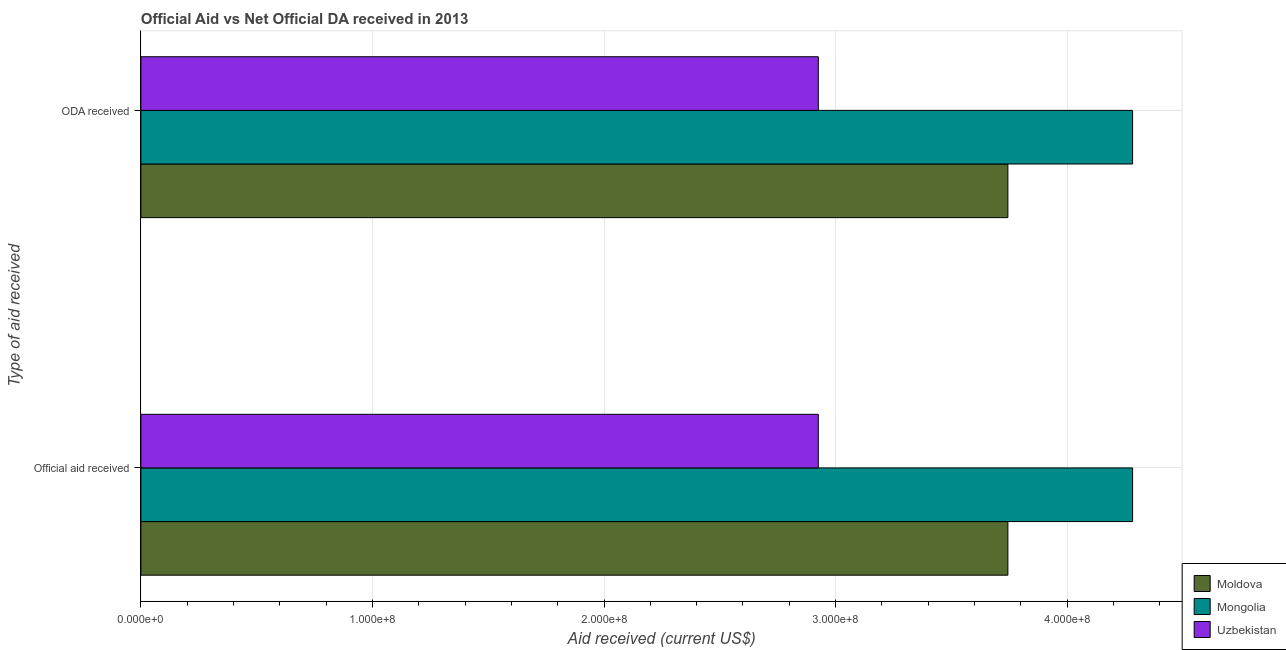How many groups of bars are there?
Your answer should be compact. 2. Are the number of bars per tick equal to the number of legend labels?
Offer a terse response. Yes. How many bars are there on the 1st tick from the top?
Keep it short and to the point. 3. What is the label of the 1st group of bars from the top?
Give a very brief answer. ODA received. What is the oda received in Moldova?
Keep it short and to the point. 3.74e+08. Across all countries, what is the maximum official aid received?
Your response must be concise. 4.28e+08. Across all countries, what is the minimum oda received?
Your answer should be very brief. 2.93e+08. In which country was the official aid received maximum?
Your answer should be very brief. Mongolia. In which country was the oda received minimum?
Give a very brief answer. Uzbekistan. What is the total oda received in the graph?
Your response must be concise. 1.10e+09. What is the difference between the official aid received in Uzbekistan and that in Moldova?
Ensure brevity in your answer.  -8.19e+07. What is the difference between the official aid received in Moldova and the oda received in Uzbekistan?
Your answer should be very brief. 8.19e+07. What is the average oda received per country?
Your answer should be compact. 3.65e+08. In how many countries, is the oda received greater than 100000000 US$?
Make the answer very short. 3. What is the ratio of the oda received in Moldova to that in Mongolia?
Offer a very short reply. 0.87. Is the official aid received in Moldova less than that in Uzbekistan?
Offer a very short reply. No. In how many countries, is the oda received greater than the average oda received taken over all countries?
Keep it short and to the point. 2. What does the 2nd bar from the top in Official aid received represents?
Provide a short and direct response. Mongolia. What does the 3rd bar from the bottom in Official aid received represents?
Your response must be concise. Uzbekistan. Are the values on the major ticks of X-axis written in scientific E-notation?
Your answer should be very brief. Yes. Does the graph contain grids?
Make the answer very short. Yes. Where does the legend appear in the graph?
Your answer should be compact. Bottom right. How many legend labels are there?
Your answer should be very brief. 3. How are the legend labels stacked?
Ensure brevity in your answer.  Vertical. What is the title of the graph?
Give a very brief answer. Official Aid vs Net Official DA received in 2013 . Does "Niger" appear as one of the legend labels in the graph?
Offer a very short reply. No. What is the label or title of the X-axis?
Make the answer very short. Aid received (current US$). What is the label or title of the Y-axis?
Provide a short and direct response. Type of aid received. What is the Aid received (current US$) of Moldova in Official aid received?
Give a very brief answer. 3.74e+08. What is the Aid received (current US$) in Mongolia in Official aid received?
Keep it short and to the point. 4.28e+08. What is the Aid received (current US$) in Uzbekistan in Official aid received?
Provide a short and direct response. 2.93e+08. What is the Aid received (current US$) of Moldova in ODA received?
Make the answer very short. 3.74e+08. What is the Aid received (current US$) of Mongolia in ODA received?
Give a very brief answer. 4.28e+08. What is the Aid received (current US$) in Uzbekistan in ODA received?
Offer a terse response. 2.93e+08. Across all Type of aid received, what is the maximum Aid received (current US$) in Moldova?
Your answer should be very brief. 3.74e+08. Across all Type of aid received, what is the maximum Aid received (current US$) in Mongolia?
Your answer should be very brief. 4.28e+08. Across all Type of aid received, what is the maximum Aid received (current US$) in Uzbekistan?
Your response must be concise. 2.93e+08. Across all Type of aid received, what is the minimum Aid received (current US$) in Moldova?
Offer a very short reply. 3.74e+08. Across all Type of aid received, what is the minimum Aid received (current US$) of Mongolia?
Your answer should be very brief. 4.28e+08. Across all Type of aid received, what is the minimum Aid received (current US$) of Uzbekistan?
Provide a short and direct response. 2.93e+08. What is the total Aid received (current US$) of Moldova in the graph?
Offer a terse response. 7.49e+08. What is the total Aid received (current US$) of Mongolia in the graph?
Ensure brevity in your answer.  8.57e+08. What is the total Aid received (current US$) in Uzbekistan in the graph?
Provide a short and direct response. 5.85e+08. What is the difference between the Aid received (current US$) in Uzbekistan in Official aid received and that in ODA received?
Your answer should be compact. 0. What is the difference between the Aid received (current US$) in Moldova in Official aid received and the Aid received (current US$) in Mongolia in ODA received?
Offer a very short reply. -5.38e+07. What is the difference between the Aid received (current US$) of Moldova in Official aid received and the Aid received (current US$) of Uzbekistan in ODA received?
Offer a very short reply. 8.19e+07. What is the difference between the Aid received (current US$) in Mongolia in Official aid received and the Aid received (current US$) in Uzbekistan in ODA received?
Provide a short and direct response. 1.36e+08. What is the average Aid received (current US$) in Moldova per Type of aid received?
Offer a terse response. 3.74e+08. What is the average Aid received (current US$) of Mongolia per Type of aid received?
Your answer should be very brief. 4.28e+08. What is the average Aid received (current US$) in Uzbekistan per Type of aid received?
Keep it short and to the point. 2.93e+08. What is the difference between the Aid received (current US$) of Moldova and Aid received (current US$) of Mongolia in Official aid received?
Your response must be concise. -5.38e+07. What is the difference between the Aid received (current US$) in Moldova and Aid received (current US$) in Uzbekistan in Official aid received?
Provide a short and direct response. 8.19e+07. What is the difference between the Aid received (current US$) in Mongolia and Aid received (current US$) in Uzbekistan in Official aid received?
Give a very brief answer. 1.36e+08. What is the difference between the Aid received (current US$) of Moldova and Aid received (current US$) of Mongolia in ODA received?
Your answer should be very brief. -5.38e+07. What is the difference between the Aid received (current US$) of Moldova and Aid received (current US$) of Uzbekistan in ODA received?
Keep it short and to the point. 8.19e+07. What is the difference between the Aid received (current US$) of Mongolia and Aid received (current US$) of Uzbekistan in ODA received?
Your answer should be compact. 1.36e+08. What is the ratio of the Aid received (current US$) of Moldova in Official aid received to that in ODA received?
Keep it short and to the point. 1. What is the difference between the highest and the second highest Aid received (current US$) of Mongolia?
Offer a very short reply. 0. What is the difference between the highest and the lowest Aid received (current US$) of Mongolia?
Make the answer very short. 0. 